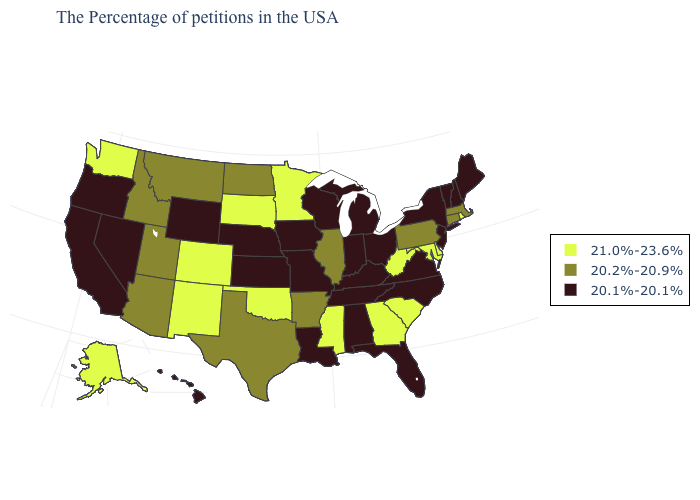Among the states that border Oregon , which have the lowest value?
Write a very short answer. Nevada, California. Does the first symbol in the legend represent the smallest category?
Keep it brief. No. How many symbols are there in the legend?
Short answer required. 3. Does Arkansas have the highest value in the USA?
Be succinct. No. What is the lowest value in the MidWest?
Answer briefly. 20.1%-20.1%. Which states have the lowest value in the USA?
Quick response, please. Maine, New Hampshire, Vermont, New York, New Jersey, Virginia, North Carolina, Ohio, Florida, Michigan, Kentucky, Indiana, Alabama, Tennessee, Wisconsin, Louisiana, Missouri, Iowa, Kansas, Nebraska, Wyoming, Nevada, California, Oregon, Hawaii. Does the map have missing data?
Answer briefly. No. Name the states that have a value in the range 20.2%-20.9%?
Concise answer only. Massachusetts, Connecticut, Pennsylvania, Illinois, Arkansas, Texas, North Dakota, Utah, Montana, Arizona, Idaho. Name the states that have a value in the range 20.1%-20.1%?
Short answer required. Maine, New Hampshire, Vermont, New York, New Jersey, Virginia, North Carolina, Ohio, Florida, Michigan, Kentucky, Indiana, Alabama, Tennessee, Wisconsin, Louisiana, Missouri, Iowa, Kansas, Nebraska, Wyoming, Nevada, California, Oregon, Hawaii. What is the lowest value in the West?
Keep it brief. 20.1%-20.1%. Name the states that have a value in the range 20.1%-20.1%?
Short answer required. Maine, New Hampshire, Vermont, New York, New Jersey, Virginia, North Carolina, Ohio, Florida, Michigan, Kentucky, Indiana, Alabama, Tennessee, Wisconsin, Louisiana, Missouri, Iowa, Kansas, Nebraska, Wyoming, Nevada, California, Oregon, Hawaii. What is the highest value in the South ?
Give a very brief answer. 21.0%-23.6%. What is the value of Oklahoma?
Write a very short answer. 21.0%-23.6%. Name the states that have a value in the range 20.1%-20.1%?
Keep it brief. Maine, New Hampshire, Vermont, New York, New Jersey, Virginia, North Carolina, Ohio, Florida, Michigan, Kentucky, Indiana, Alabama, Tennessee, Wisconsin, Louisiana, Missouri, Iowa, Kansas, Nebraska, Wyoming, Nevada, California, Oregon, Hawaii. 